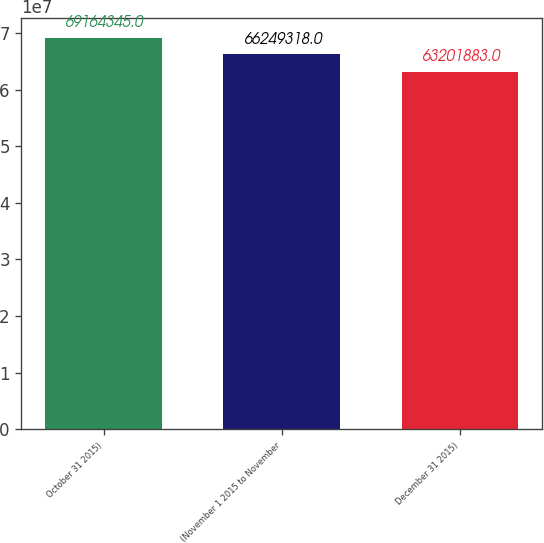Convert chart. <chart><loc_0><loc_0><loc_500><loc_500><bar_chart><fcel>October 31 2015)<fcel>(November 1 2015 to November<fcel>December 31 2015)<nl><fcel>6.91643e+07<fcel>6.62493e+07<fcel>6.32019e+07<nl></chart> 